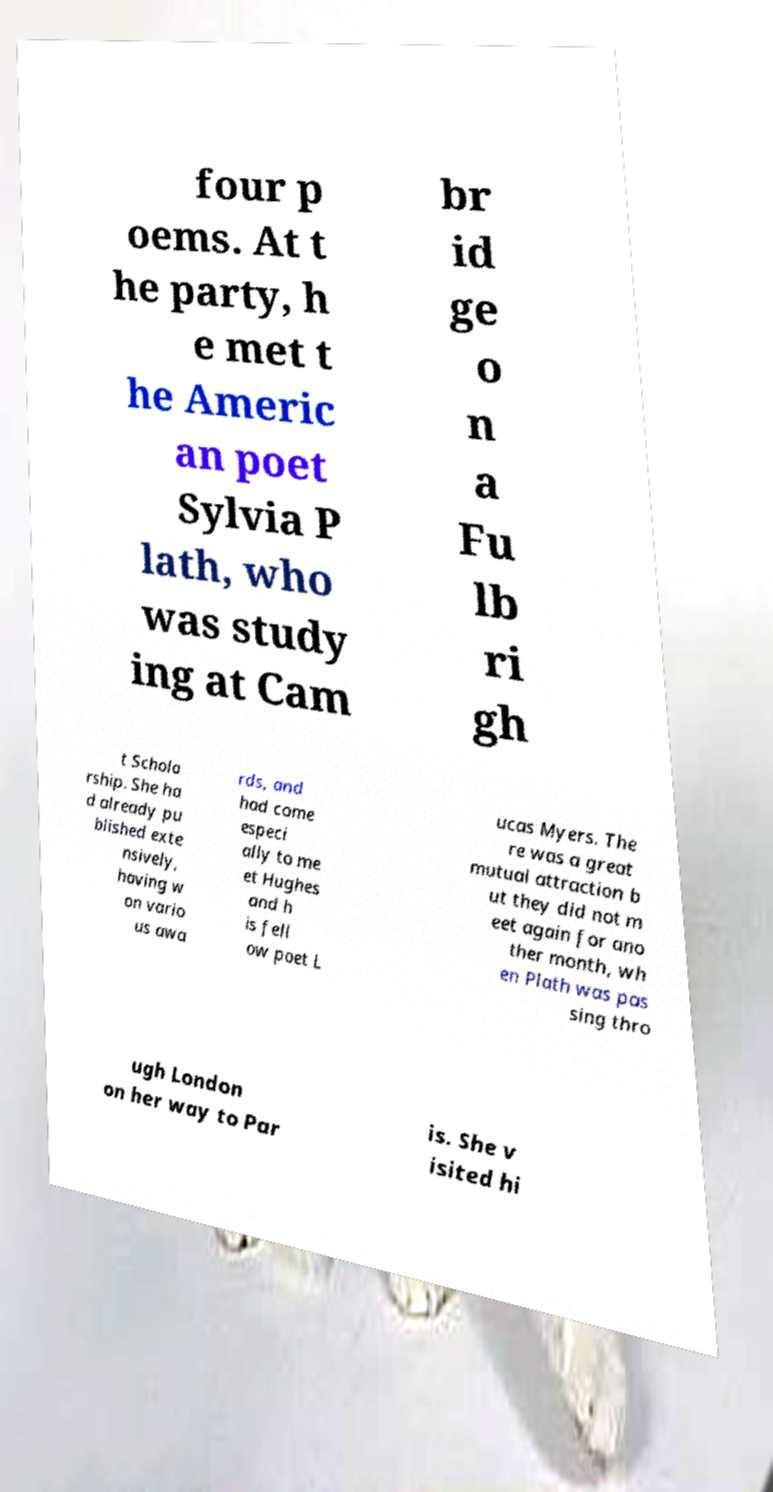For documentation purposes, I need the text within this image transcribed. Could you provide that? four p oems. At t he party, h e met t he Americ an poet Sylvia P lath, who was study ing at Cam br id ge o n a Fu lb ri gh t Schola rship. She ha d already pu blished exte nsively, having w on vario us awa rds, and had come especi ally to me et Hughes and h is fell ow poet L ucas Myers. The re was a great mutual attraction b ut they did not m eet again for ano ther month, wh en Plath was pas sing thro ugh London on her way to Par is. She v isited hi 